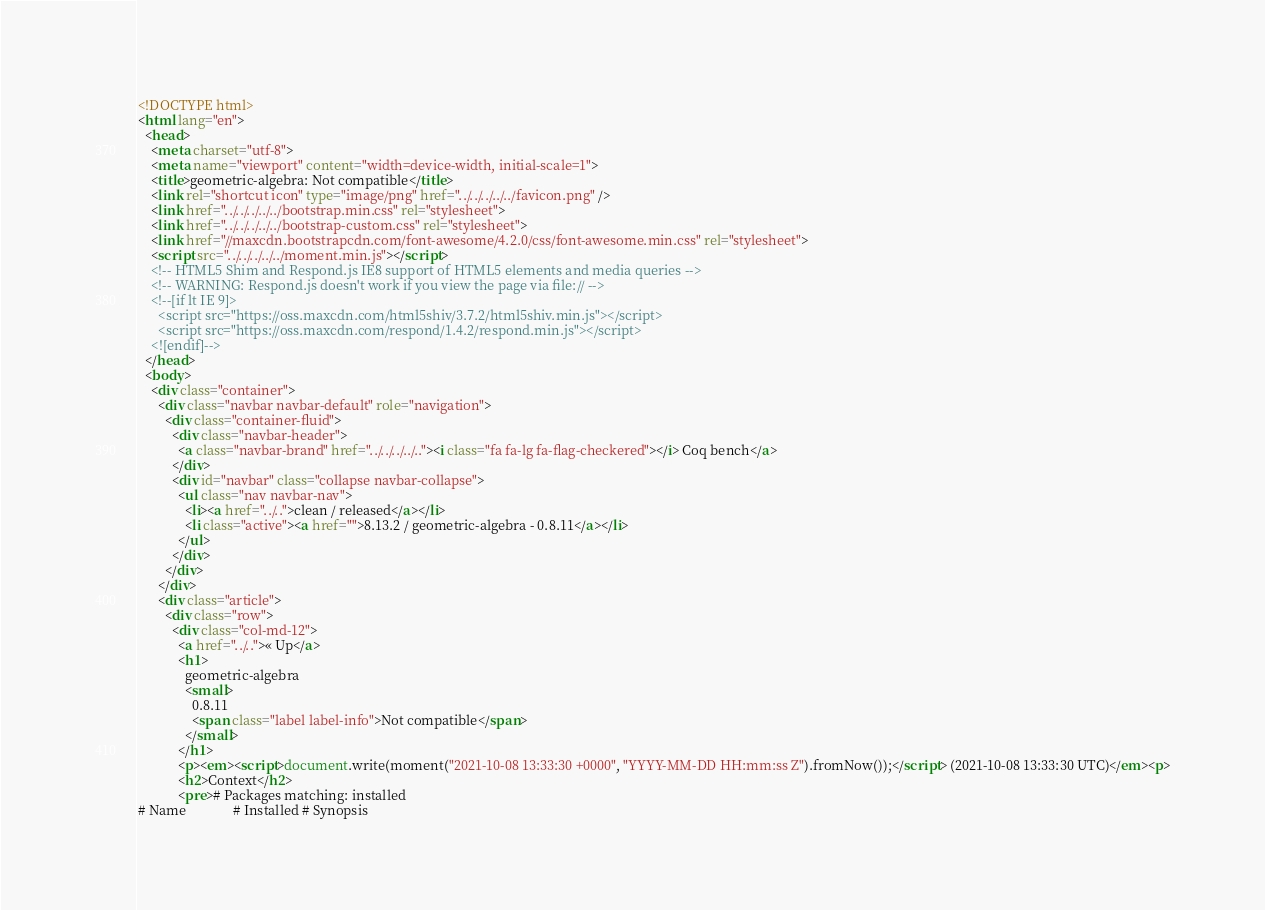Convert code to text. <code><loc_0><loc_0><loc_500><loc_500><_HTML_><!DOCTYPE html>
<html lang="en">
  <head>
    <meta charset="utf-8">
    <meta name="viewport" content="width=device-width, initial-scale=1">
    <title>geometric-algebra: Not compatible</title>
    <link rel="shortcut icon" type="image/png" href="../../../../../favicon.png" />
    <link href="../../../../../bootstrap.min.css" rel="stylesheet">
    <link href="../../../../../bootstrap-custom.css" rel="stylesheet">
    <link href="//maxcdn.bootstrapcdn.com/font-awesome/4.2.0/css/font-awesome.min.css" rel="stylesheet">
    <script src="../../../../../moment.min.js"></script>
    <!-- HTML5 Shim and Respond.js IE8 support of HTML5 elements and media queries -->
    <!-- WARNING: Respond.js doesn't work if you view the page via file:// -->
    <!--[if lt IE 9]>
      <script src="https://oss.maxcdn.com/html5shiv/3.7.2/html5shiv.min.js"></script>
      <script src="https://oss.maxcdn.com/respond/1.4.2/respond.min.js"></script>
    <![endif]-->
  </head>
  <body>
    <div class="container">
      <div class="navbar navbar-default" role="navigation">
        <div class="container-fluid">
          <div class="navbar-header">
            <a class="navbar-brand" href="../../../../.."><i class="fa fa-lg fa-flag-checkered"></i> Coq bench</a>
          </div>
          <div id="navbar" class="collapse navbar-collapse">
            <ul class="nav navbar-nav">
              <li><a href="../..">clean / released</a></li>
              <li class="active"><a href="">8.13.2 / geometric-algebra - 0.8.11</a></li>
            </ul>
          </div>
        </div>
      </div>
      <div class="article">
        <div class="row">
          <div class="col-md-12">
            <a href="../..">« Up</a>
            <h1>
              geometric-algebra
              <small>
                0.8.11
                <span class="label label-info">Not compatible</span>
              </small>
            </h1>
            <p><em><script>document.write(moment("2021-10-08 13:33:30 +0000", "YYYY-MM-DD HH:mm:ss Z").fromNow());</script> (2021-10-08 13:33:30 UTC)</em><p>
            <h2>Context</h2>
            <pre># Packages matching: installed
# Name              # Installed # Synopsis</code> 